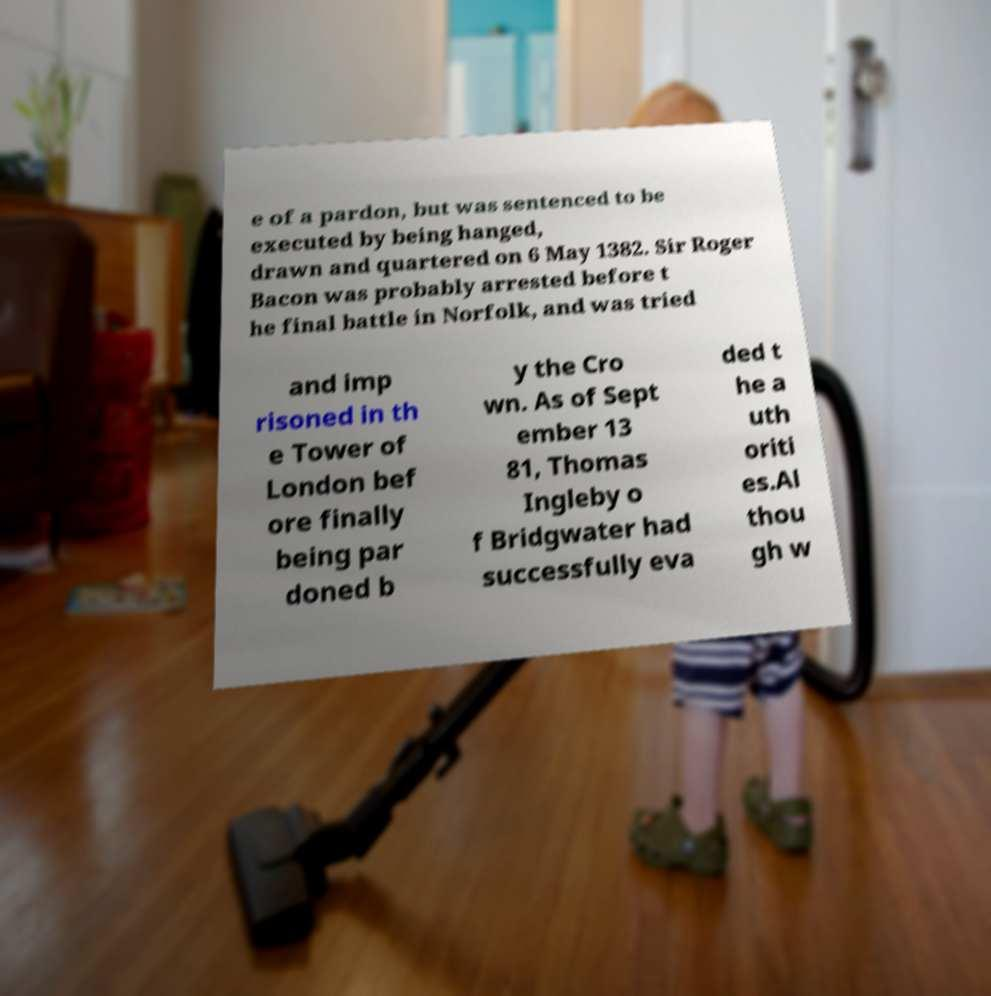Can you read and provide the text displayed in the image?This photo seems to have some interesting text. Can you extract and type it out for me? e of a pardon, but was sentenced to be executed by being hanged, drawn and quartered on 6 May 1382. Sir Roger Bacon was probably arrested before t he final battle in Norfolk, and was tried and imp risoned in th e Tower of London bef ore finally being par doned b y the Cro wn. As of Sept ember 13 81, Thomas Ingleby o f Bridgwater had successfully eva ded t he a uth oriti es.Al thou gh w 